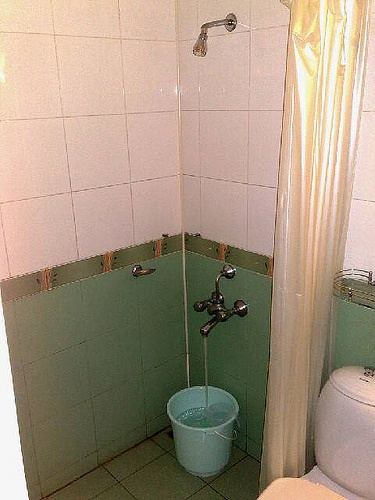Describe the objects in this image and their specific colors. I can see a toilet in beige, darkgray, tan, and gray tones in this image. 